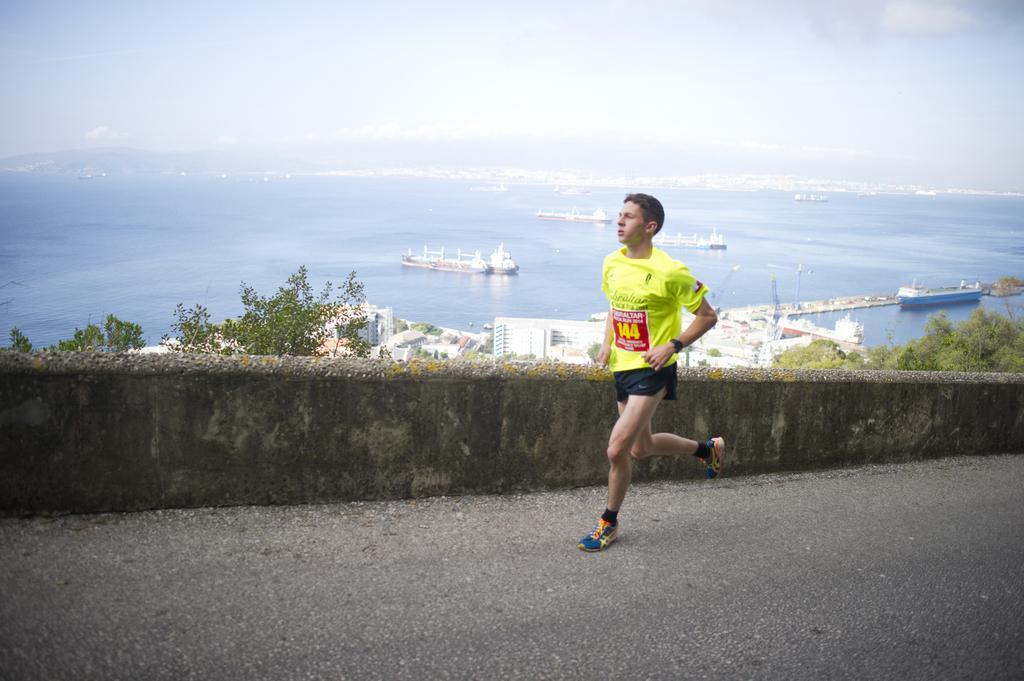Describe this image in one or two sentences. In this image I can see a person wearing yellow and black colored dress is running on the ground. I can see the wall, few trees which are green in color, few buildings which are white and brown in color, the water and few boats which are white and blue in color on the surface of the water. In the background I can see the water, few boats on the water and the sky. 